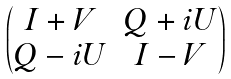Convert formula to latex. <formula><loc_0><loc_0><loc_500><loc_500>\begin{pmatrix} I + V & Q + i U \\ Q - i U & I - V \end{pmatrix}</formula> 